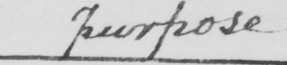Please transcribe the handwritten text in this image. purpose 